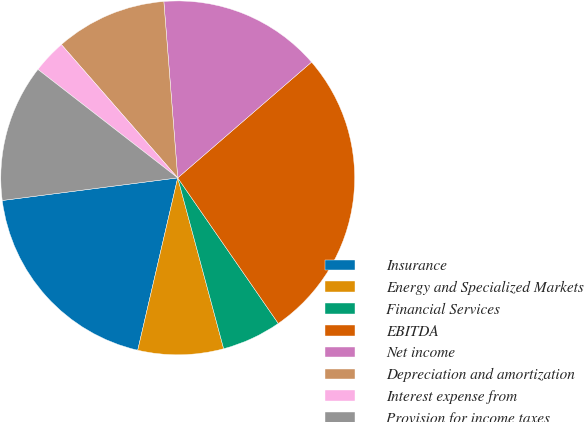Convert chart to OTSL. <chart><loc_0><loc_0><loc_500><loc_500><pie_chart><fcel>Insurance<fcel>Energy and Specialized Markets<fcel>Financial Services<fcel>EBITDA<fcel>Net income<fcel>Depreciation and amortization<fcel>Interest expense from<fcel>Provision for income taxes<nl><fcel>19.33%<fcel>7.81%<fcel>5.44%<fcel>26.73%<fcel>14.9%<fcel>10.17%<fcel>3.08%<fcel>12.54%<nl></chart> 